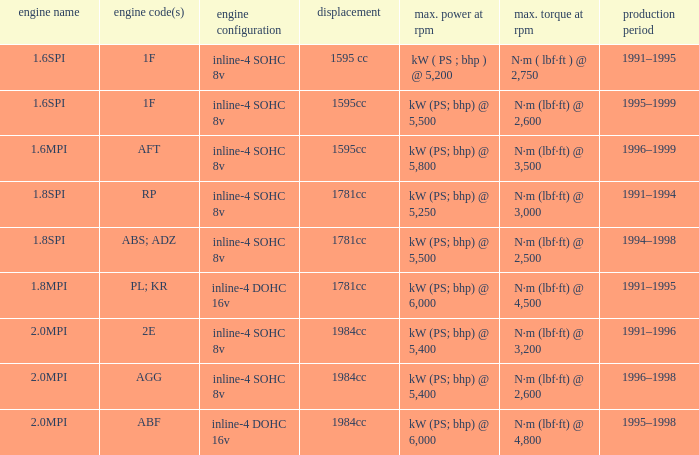What is the maximum power of engine code 2e? Kw (ps; bhp) @ 5,400. 